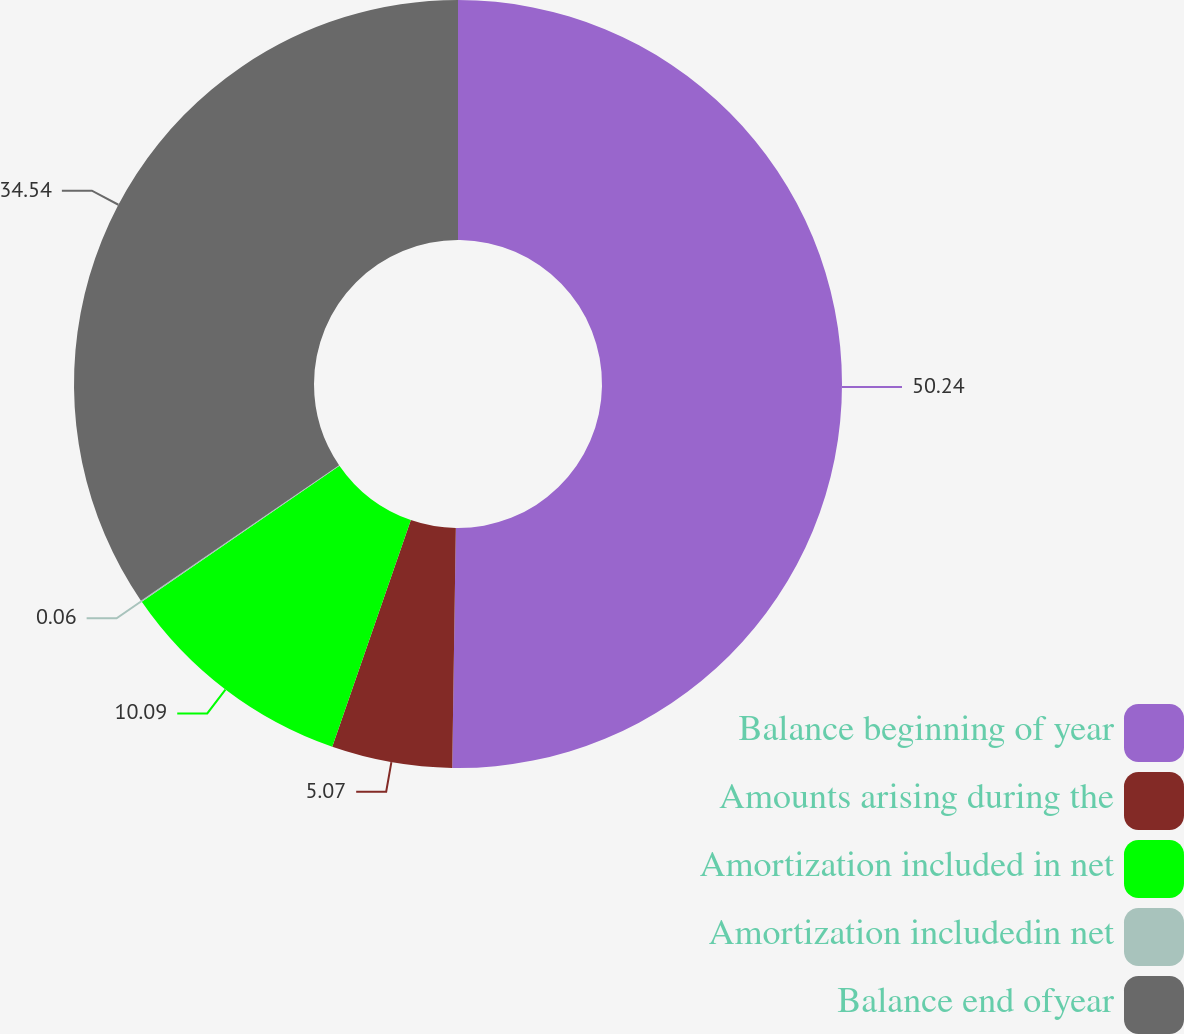Convert chart to OTSL. <chart><loc_0><loc_0><loc_500><loc_500><pie_chart><fcel>Balance beginning of year<fcel>Amounts arising during the<fcel>Amortization included in net<fcel>Amortization includedin net<fcel>Balance end ofyear<nl><fcel>50.24%<fcel>5.07%<fcel>10.09%<fcel>0.06%<fcel>34.54%<nl></chart> 